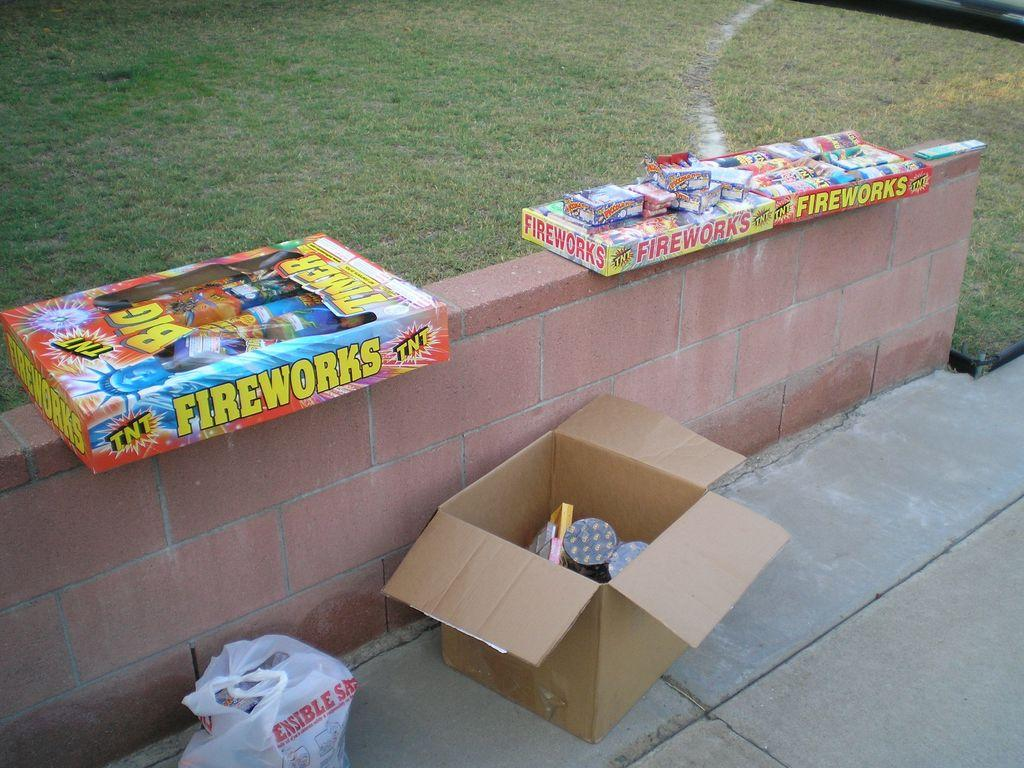Where was the image taken? The image was clicked outside. What type of vegetation is visible at the top of the image? There is grass at the top of the image. What objects are in the middle of the image? There are boxes in the middle of the image. What is covering the bottom of the image? There is a cover at the bottom of the image. What is inside the boxes? There are fireworks inside the boxes. What type of vest can be seen on the robin in the image? There is no robin or vest present in the image. What type of liquid is visible in the image? There is no liquid visible in the image. 